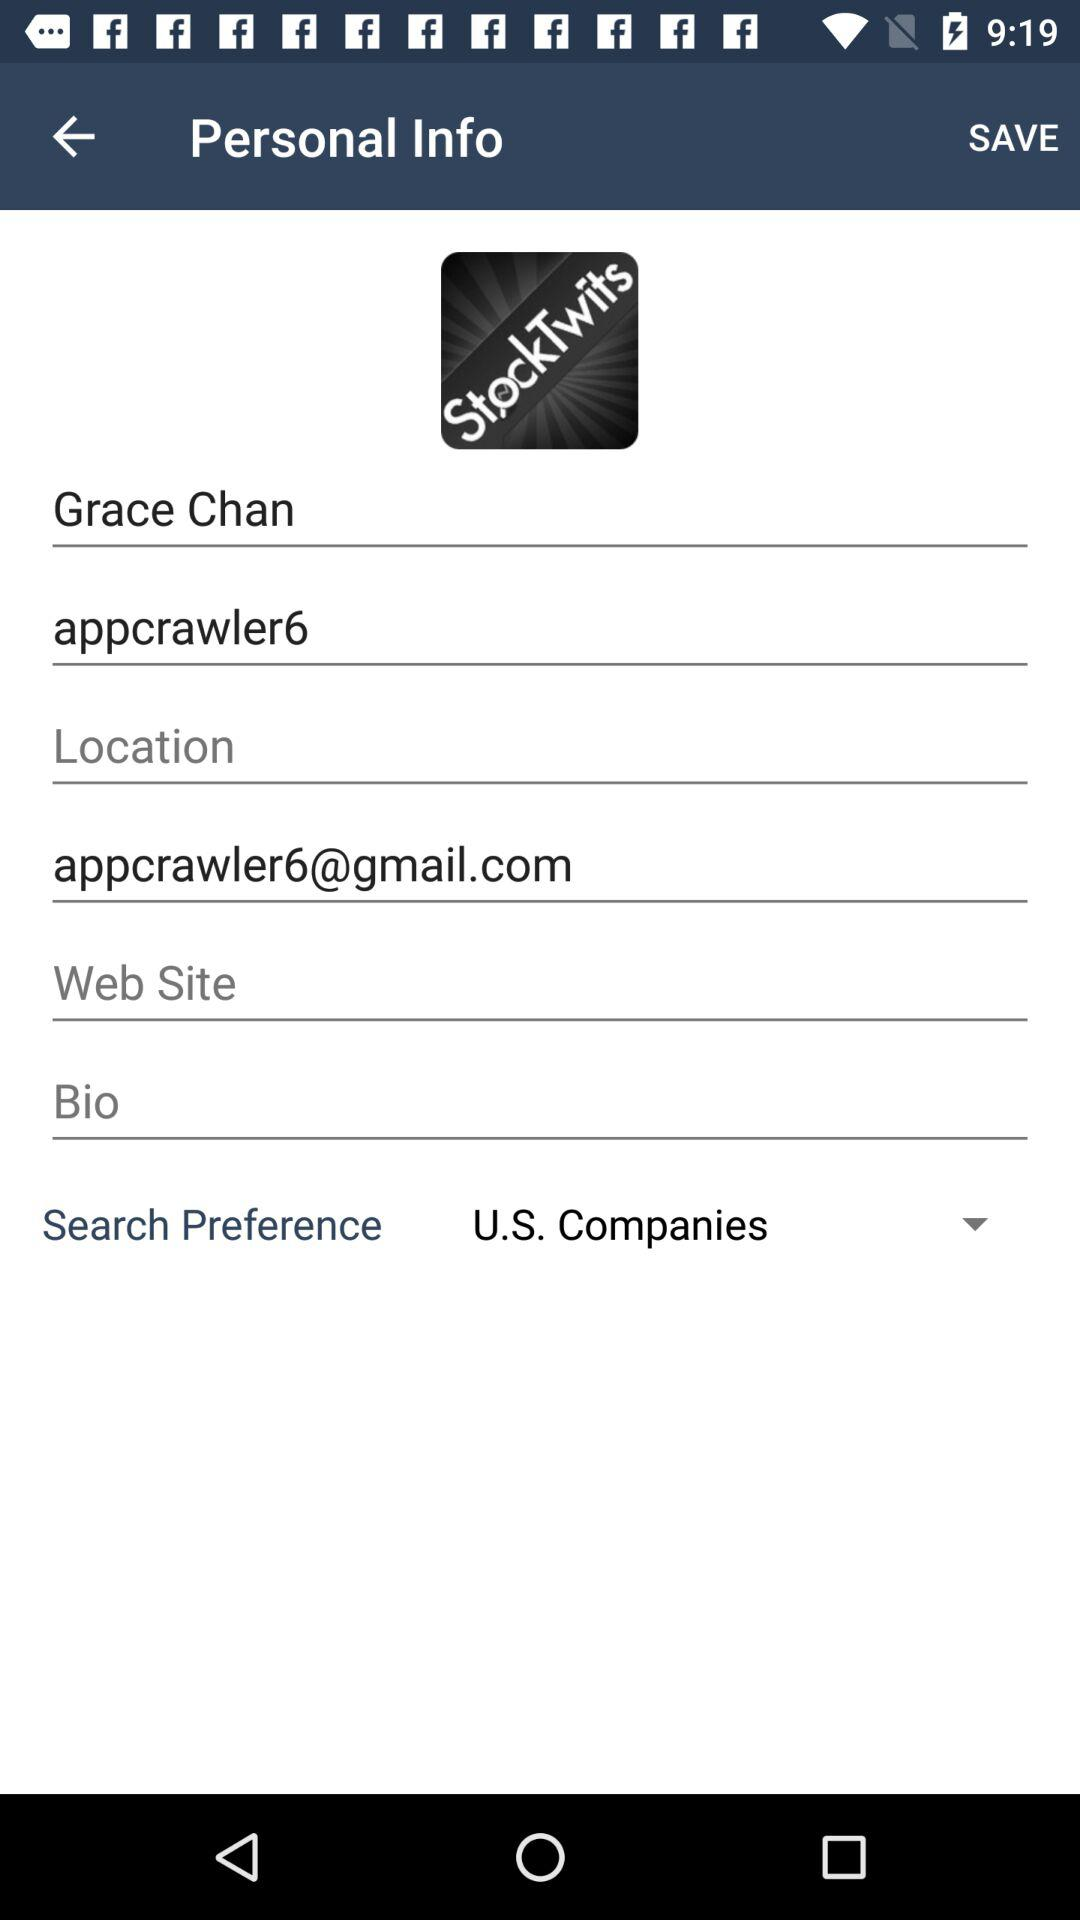What is the email ID of the user? The email ID of the user is appcrawler6@gmail.com. 